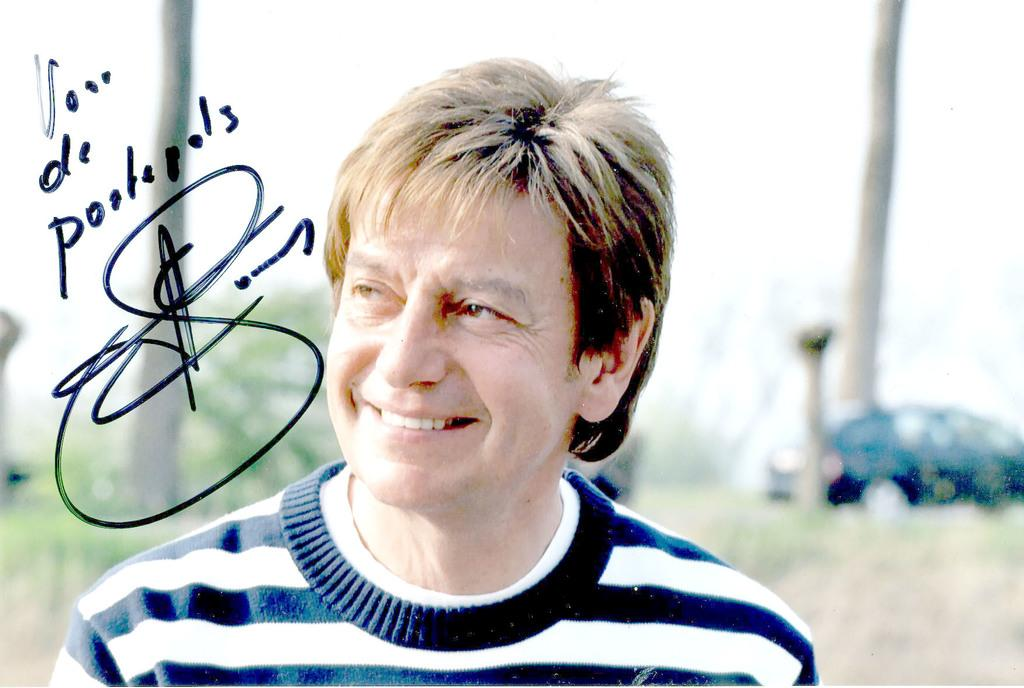What is located in the foreground of the image? There is a man in the foreground of the image, along with some text. What can be seen in the background of the image? There are trees, vehicles, grass, and the sky visible in the background of the image. What is the weather like in the image? The image appears to have been taken on a sunny day, as indicated by the clear sky. What type of office furniture can be seen in the image? There is no office furniture present in the image. What color is the action figure in the image? There is no action figure present in the image. 